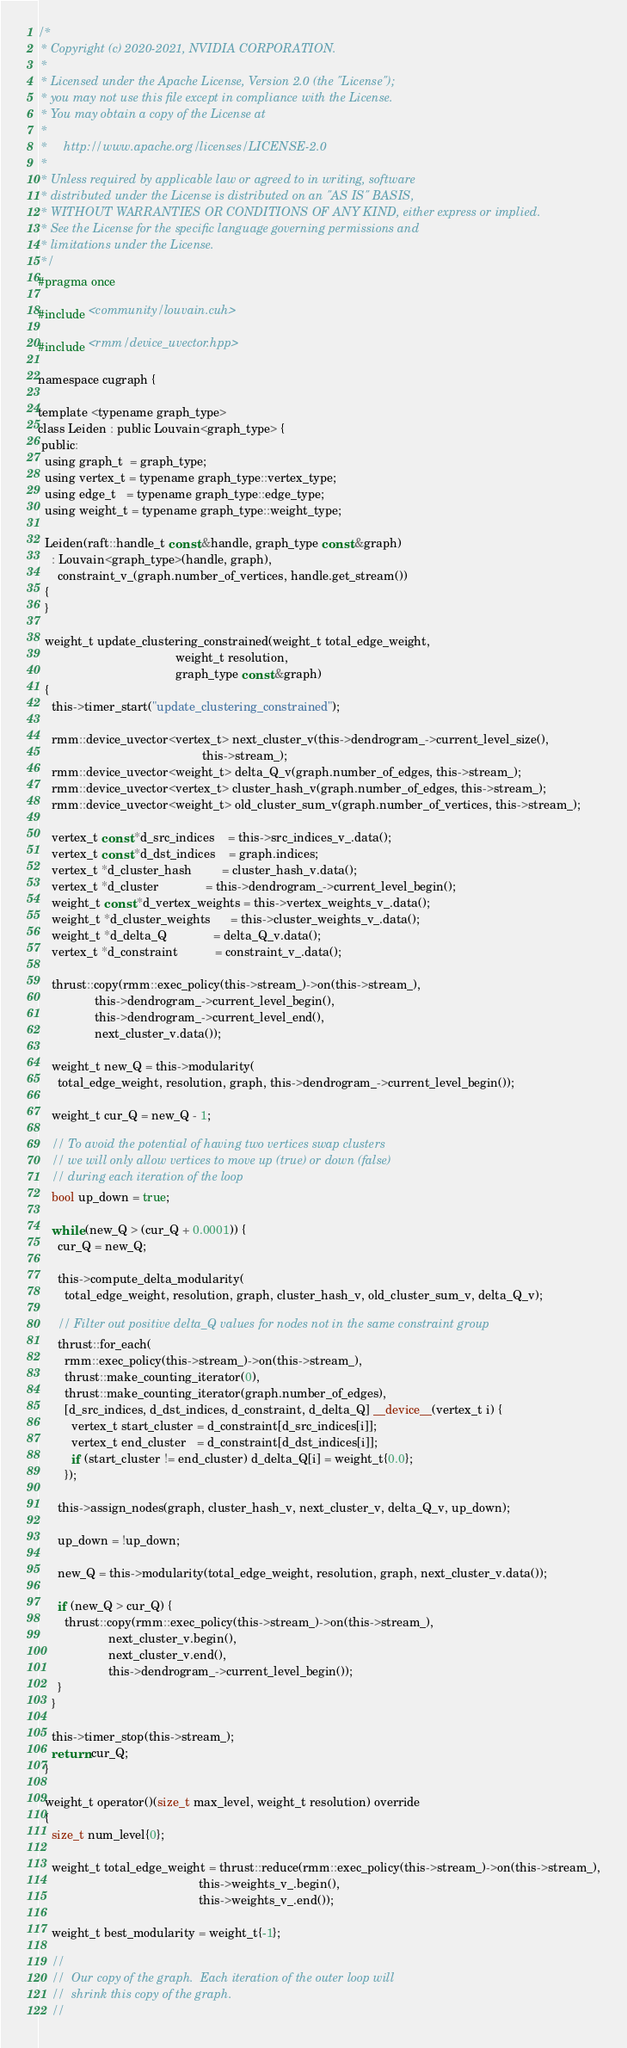<code> <loc_0><loc_0><loc_500><loc_500><_Cuda_>/*
 * Copyright (c) 2020-2021, NVIDIA CORPORATION.
 *
 * Licensed under the Apache License, Version 2.0 (the "License");
 * you may not use this file except in compliance with the License.
 * You may obtain a copy of the License at
 *
 *     http://www.apache.org/licenses/LICENSE-2.0
 *
 * Unless required by applicable law or agreed to in writing, software
 * distributed under the License is distributed on an "AS IS" BASIS,
 * WITHOUT WARRANTIES OR CONDITIONS OF ANY KIND, either express or implied.
 * See the License for the specific language governing permissions and
 * limitations under the License.
 */
#pragma once

#include <community/louvain.cuh>

#include <rmm/device_uvector.hpp>

namespace cugraph {

template <typename graph_type>
class Leiden : public Louvain<graph_type> {
 public:
  using graph_t  = graph_type;
  using vertex_t = typename graph_type::vertex_type;
  using edge_t   = typename graph_type::edge_type;
  using weight_t = typename graph_type::weight_type;

  Leiden(raft::handle_t const &handle, graph_type const &graph)
    : Louvain<graph_type>(handle, graph),
      constraint_v_(graph.number_of_vertices, handle.get_stream())
  {
  }

  weight_t update_clustering_constrained(weight_t total_edge_weight,
                                         weight_t resolution,
                                         graph_type const &graph)
  {
    this->timer_start("update_clustering_constrained");

    rmm::device_uvector<vertex_t> next_cluster_v(this->dendrogram_->current_level_size(),
                                                 this->stream_);
    rmm::device_uvector<weight_t> delta_Q_v(graph.number_of_edges, this->stream_);
    rmm::device_uvector<vertex_t> cluster_hash_v(graph.number_of_edges, this->stream_);
    rmm::device_uvector<weight_t> old_cluster_sum_v(graph.number_of_vertices, this->stream_);

    vertex_t const *d_src_indices    = this->src_indices_v_.data();
    vertex_t const *d_dst_indices    = graph.indices;
    vertex_t *d_cluster_hash         = cluster_hash_v.data();
    vertex_t *d_cluster              = this->dendrogram_->current_level_begin();
    weight_t const *d_vertex_weights = this->vertex_weights_v_.data();
    weight_t *d_cluster_weights      = this->cluster_weights_v_.data();
    weight_t *d_delta_Q              = delta_Q_v.data();
    vertex_t *d_constraint           = constraint_v_.data();

    thrust::copy(rmm::exec_policy(this->stream_)->on(this->stream_),
                 this->dendrogram_->current_level_begin(),
                 this->dendrogram_->current_level_end(),
                 next_cluster_v.data());

    weight_t new_Q = this->modularity(
      total_edge_weight, resolution, graph, this->dendrogram_->current_level_begin());

    weight_t cur_Q = new_Q - 1;

    // To avoid the potential of having two vertices swap clusters
    // we will only allow vertices to move up (true) or down (false)
    // during each iteration of the loop
    bool up_down = true;

    while (new_Q > (cur_Q + 0.0001)) {
      cur_Q = new_Q;

      this->compute_delta_modularity(
        total_edge_weight, resolution, graph, cluster_hash_v, old_cluster_sum_v, delta_Q_v);

      // Filter out positive delta_Q values for nodes not in the same constraint group
      thrust::for_each(
        rmm::exec_policy(this->stream_)->on(this->stream_),
        thrust::make_counting_iterator(0),
        thrust::make_counting_iterator(graph.number_of_edges),
        [d_src_indices, d_dst_indices, d_constraint, d_delta_Q] __device__(vertex_t i) {
          vertex_t start_cluster = d_constraint[d_src_indices[i]];
          vertex_t end_cluster   = d_constraint[d_dst_indices[i]];
          if (start_cluster != end_cluster) d_delta_Q[i] = weight_t{0.0};
        });

      this->assign_nodes(graph, cluster_hash_v, next_cluster_v, delta_Q_v, up_down);

      up_down = !up_down;

      new_Q = this->modularity(total_edge_weight, resolution, graph, next_cluster_v.data());

      if (new_Q > cur_Q) {
        thrust::copy(rmm::exec_policy(this->stream_)->on(this->stream_),
                     next_cluster_v.begin(),
                     next_cluster_v.end(),
                     this->dendrogram_->current_level_begin());
      }
    }

    this->timer_stop(this->stream_);
    return cur_Q;
  }

  weight_t operator()(size_t max_level, weight_t resolution) override
  {
    size_t num_level{0};

    weight_t total_edge_weight = thrust::reduce(rmm::exec_policy(this->stream_)->on(this->stream_),
                                                this->weights_v_.begin(),
                                                this->weights_v_.end());

    weight_t best_modularity = weight_t{-1};

    //
    //  Our copy of the graph.  Each iteration of the outer loop will
    //  shrink this copy of the graph.
    //</code> 